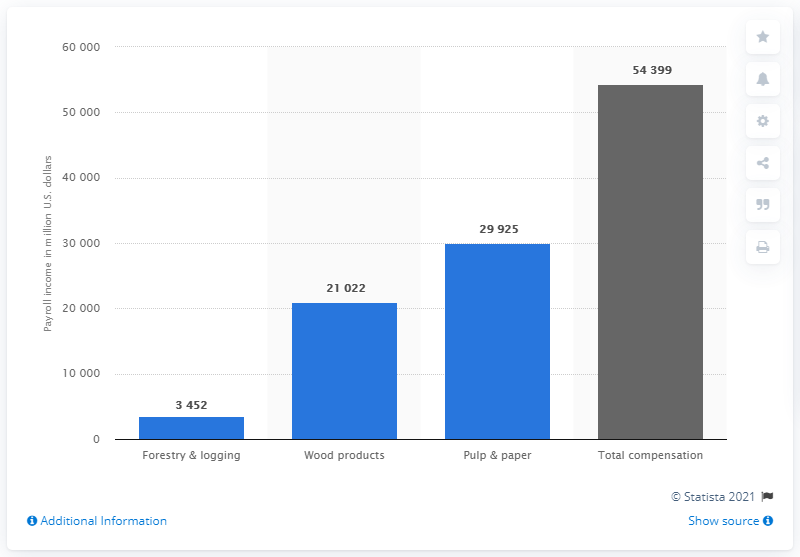Identify some key points in this picture. The total compensation of the U.S. forest products industry as of 2018 was $54,399. 